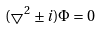Convert formula to latex. <formula><loc_0><loc_0><loc_500><loc_500>( \bigtriangledown ^ { 2 } \pm i ) \Phi = 0</formula> 